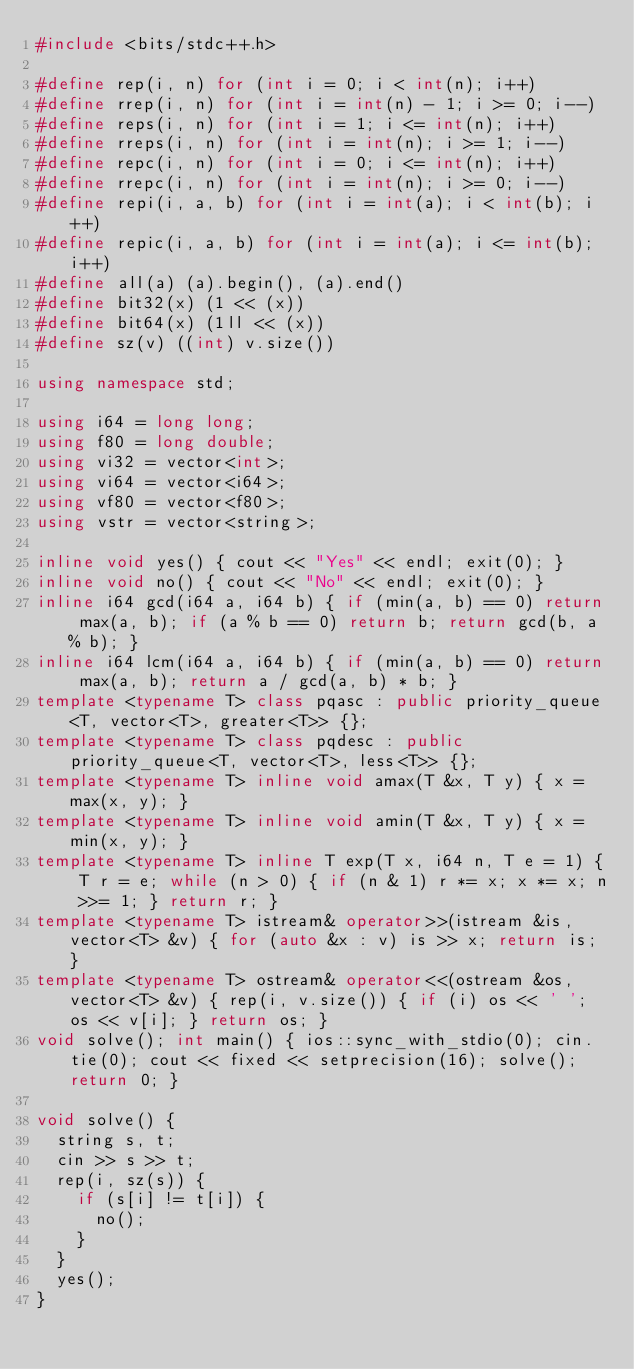Convert code to text. <code><loc_0><loc_0><loc_500><loc_500><_C++_>#include <bits/stdc++.h>

#define rep(i, n) for (int i = 0; i < int(n); i++)
#define rrep(i, n) for (int i = int(n) - 1; i >= 0; i--)
#define reps(i, n) for (int i = 1; i <= int(n); i++)
#define rreps(i, n) for (int i = int(n); i >= 1; i--)
#define repc(i, n) for (int i = 0; i <= int(n); i++)
#define rrepc(i, n) for (int i = int(n); i >= 0; i--)
#define repi(i, a, b) for (int i = int(a); i < int(b); i++)
#define repic(i, a, b) for (int i = int(a); i <= int(b); i++)
#define all(a) (a).begin(), (a).end()
#define bit32(x) (1 << (x))
#define bit64(x) (1ll << (x))
#define sz(v) ((int) v.size())

using namespace std;

using i64 = long long;
using f80 = long double;
using vi32 = vector<int>;
using vi64 = vector<i64>;
using vf80 = vector<f80>;
using vstr = vector<string>;

inline void yes() { cout << "Yes" << endl; exit(0); }
inline void no() { cout << "No" << endl; exit(0); }
inline i64 gcd(i64 a, i64 b) { if (min(a, b) == 0) return max(a, b); if (a % b == 0) return b; return gcd(b, a % b); }
inline i64 lcm(i64 a, i64 b) { if (min(a, b) == 0) return max(a, b); return a / gcd(a, b) * b; }
template <typename T> class pqasc : public priority_queue<T, vector<T>, greater<T>> {};
template <typename T> class pqdesc : public priority_queue<T, vector<T>, less<T>> {};
template <typename T> inline void amax(T &x, T y) { x = max(x, y); }
template <typename T> inline void amin(T &x, T y) { x = min(x, y); }
template <typename T> inline T exp(T x, i64 n, T e = 1) { T r = e; while (n > 0) { if (n & 1) r *= x; x *= x; n >>= 1; } return r; }
template <typename T> istream& operator>>(istream &is, vector<T> &v) { for (auto &x : v) is >> x; return is; }
template <typename T> ostream& operator<<(ostream &os, vector<T> &v) { rep(i, v.size()) { if (i) os << ' '; os << v[i]; } return os; }
void solve(); int main() { ios::sync_with_stdio(0); cin.tie(0); cout << fixed << setprecision(16); solve(); return 0; }

void solve() {
  string s, t;
  cin >> s >> t;
  rep(i, sz(s)) {
    if (s[i] != t[i]) {
      no();
    }
  }
  yes();
}
</code> 